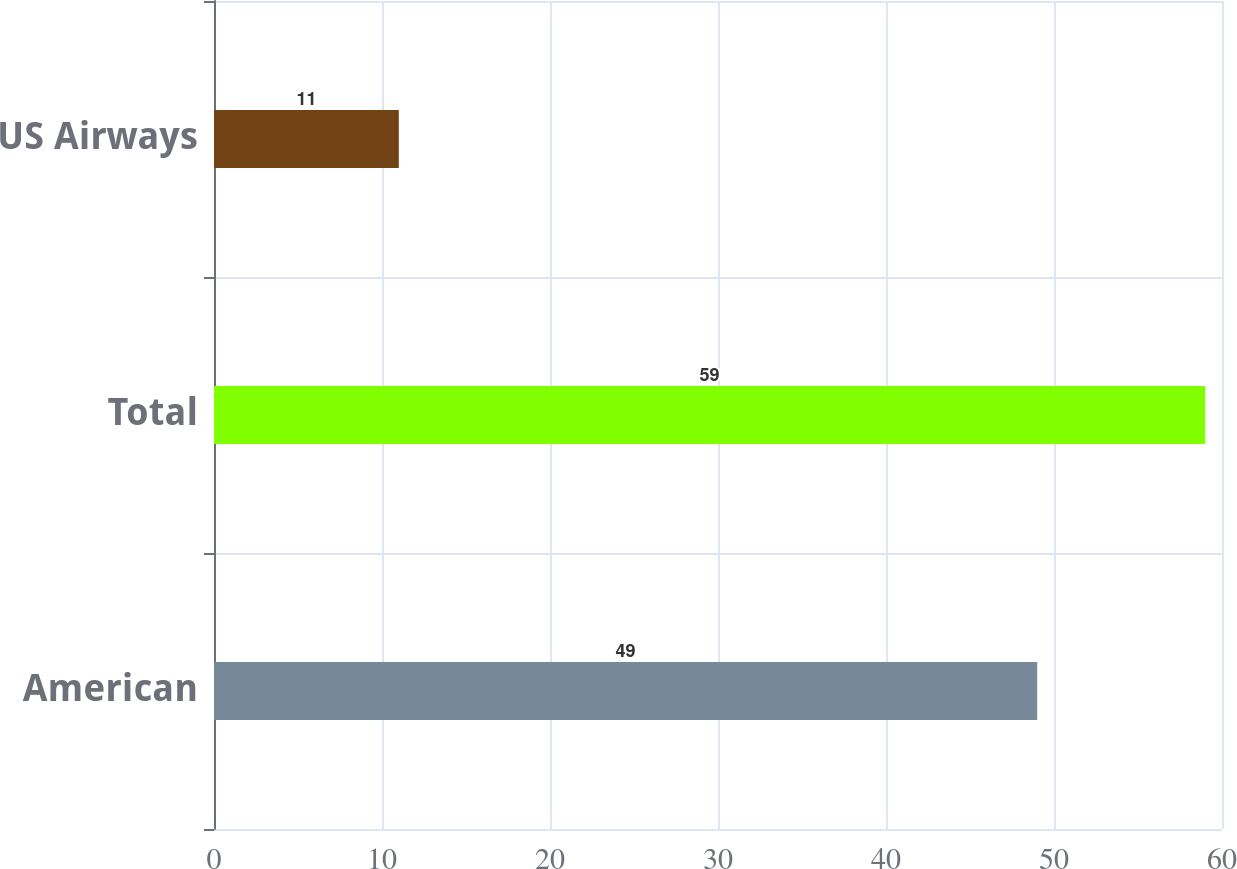<chart> <loc_0><loc_0><loc_500><loc_500><bar_chart><fcel>American<fcel>Total<fcel>US Airways<nl><fcel>49<fcel>59<fcel>11<nl></chart> 